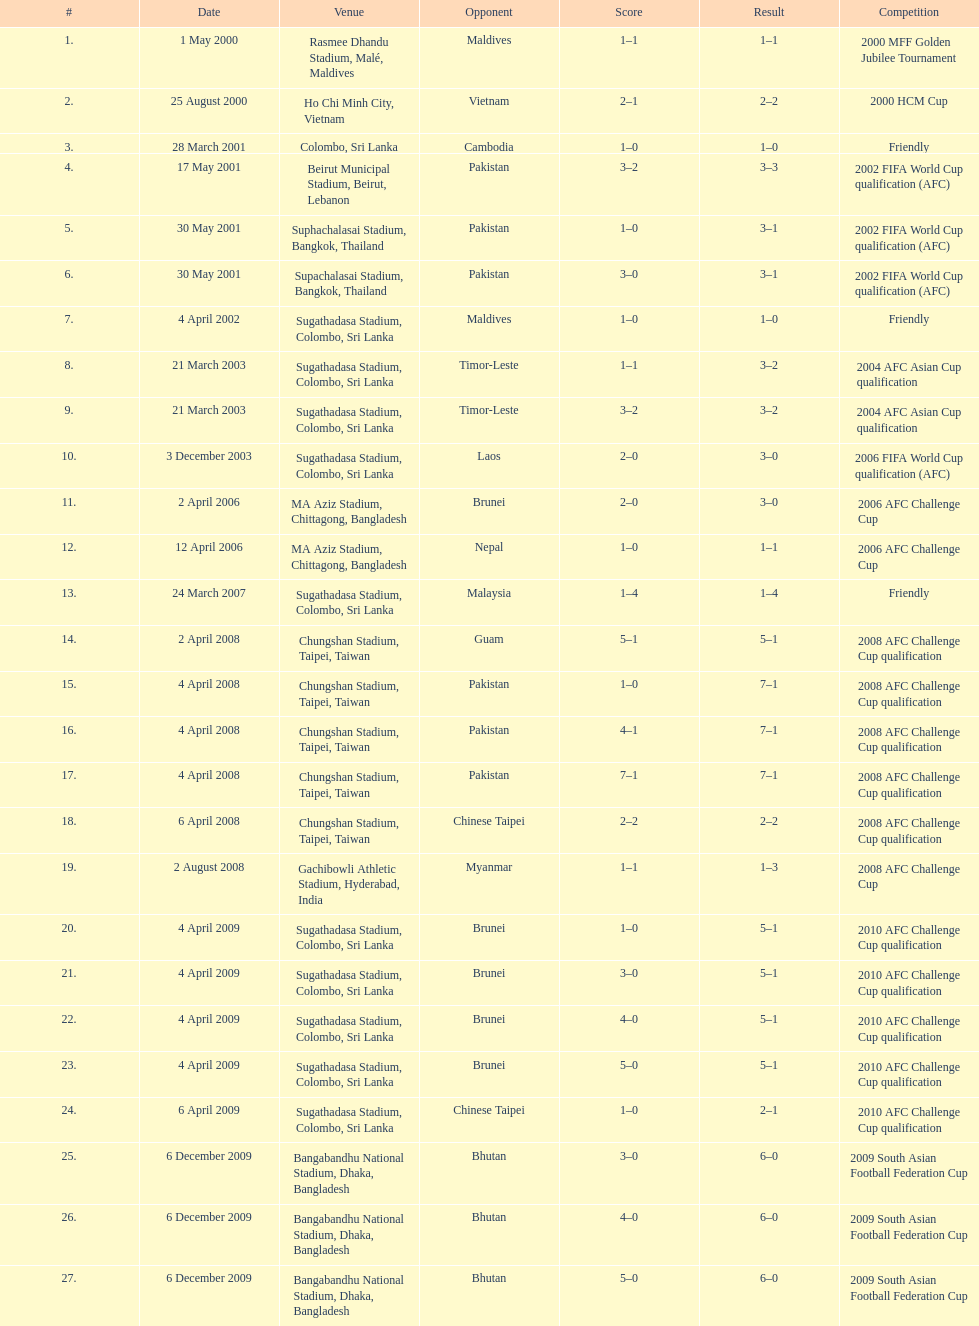What was the subsequent location after colombo, sri lanka on march 28? Beirut Municipal Stadium, Beirut, Lebanon. 